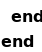Convert code to text. <code><loc_0><loc_0><loc_500><loc_500><_Ruby_>  end
end
</code> 